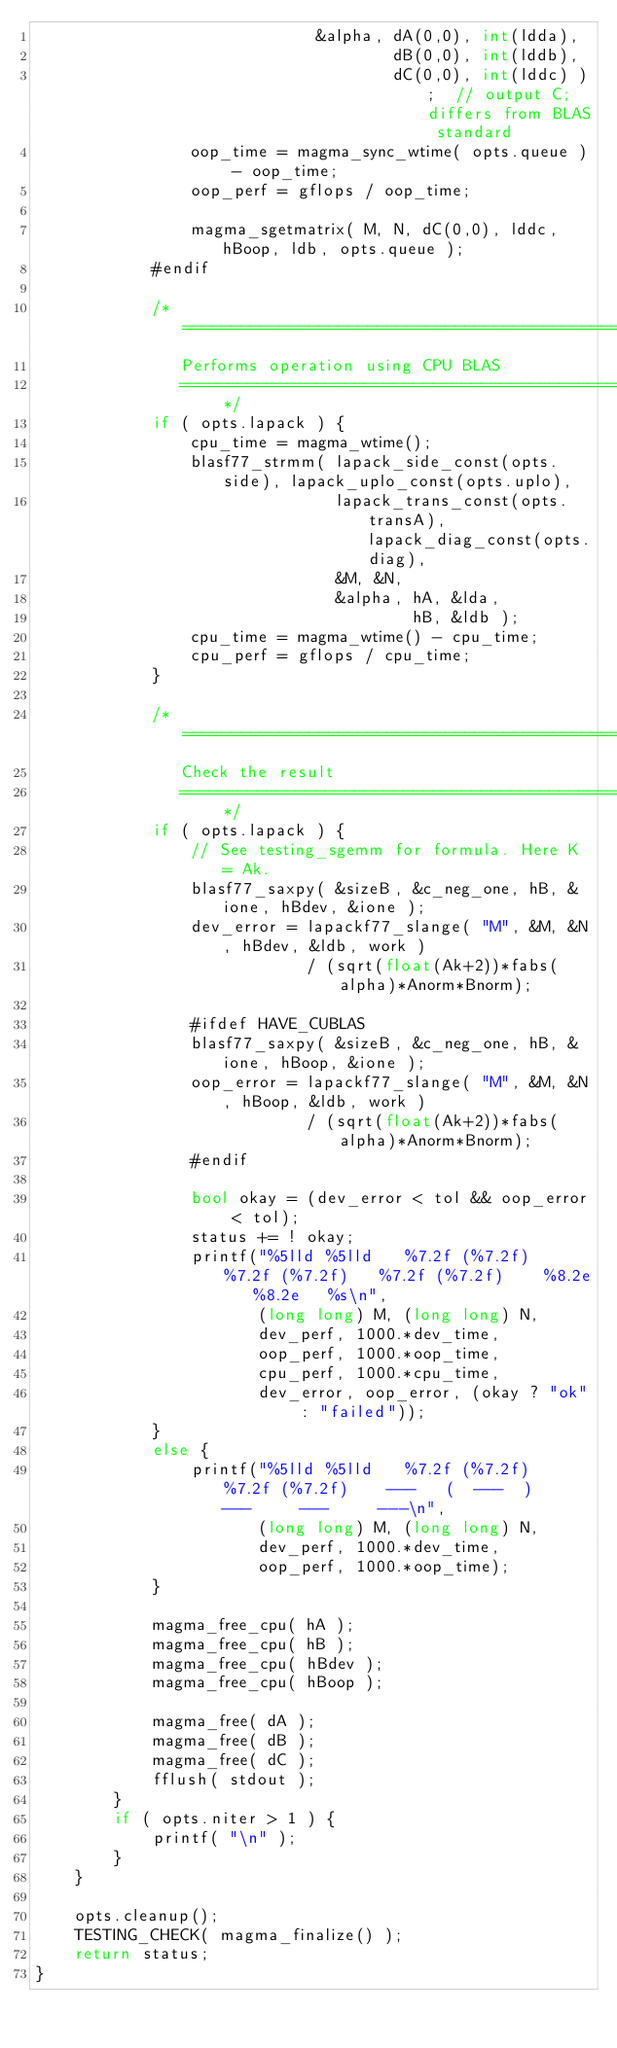<code> <loc_0><loc_0><loc_500><loc_500><_C++_>                             &alpha, dA(0,0), int(ldda),
                                     dB(0,0), int(lddb),
                                     dC(0,0), int(lddc) );  // output C; differs from BLAS standard
                oop_time = magma_sync_wtime( opts.queue ) - oop_time;
                oop_perf = gflops / oop_time;
                
                magma_sgetmatrix( M, N, dC(0,0), lddc, hBoop, ldb, opts.queue );
            #endif
            
            /* =====================================================================
               Performs operation using CPU BLAS
               =================================================================== */
            if ( opts.lapack ) {
                cpu_time = magma_wtime();
                blasf77_strmm( lapack_side_const(opts.side), lapack_uplo_const(opts.uplo),
                               lapack_trans_const(opts.transA), lapack_diag_const(opts.diag),
                               &M, &N,
                               &alpha, hA, &lda,
                                       hB, &ldb );
                cpu_time = magma_wtime() - cpu_time;
                cpu_perf = gflops / cpu_time;
            }
            
            /* =====================================================================
               Check the result
               =================================================================== */
            if ( opts.lapack ) {
                // See testing_sgemm for formula. Here K = Ak.
                blasf77_saxpy( &sizeB, &c_neg_one, hB, &ione, hBdev, &ione );
                dev_error = lapackf77_slange( "M", &M, &N, hBdev, &ldb, work )
                            / (sqrt(float(Ak+2))*fabs(alpha)*Anorm*Bnorm);
                
                #ifdef HAVE_CUBLAS
                blasf77_saxpy( &sizeB, &c_neg_one, hB, &ione, hBoop, &ione );
                oop_error = lapackf77_slange( "M", &M, &N, hBoop, &ldb, work )
                            / (sqrt(float(Ak+2))*fabs(alpha)*Anorm*Bnorm);
                #endif
                
                bool okay = (dev_error < tol && oop_error < tol);
                status += ! okay;
                printf("%5lld %5lld   %7.2f (%7.2f)   %7.2f (%7.2f)   %7.2f (%7.2f)    %8.2e   %8.2e   %s\n",
                       (long long) M, (long long) N,
                       dev_perf, 1000.*dev_time,
                       oop_perf, 1000.*oop_time,
                       cpu_perf, 1000.*cpu_time,
                       dev_error, oop_error, (okay ? "ok" : "failed"));
            }
            else {
                printf("%5lld %5lld   %7.2f (%7.2f)   %7.2f (%7.2f)    ---   (  ---  )    ---     ---     ---\n",
                       (long long) M, (long long) N,
                       dev_perf, 1000.*dev_time,
                       oop_perf, 1000.*oop_time);
            }
            
            magma_free_cpu( hA );
            magma_free_cpu( hB );
            magma_free_cpu( hBdev );
            magma_free_cpu( hBoop );
            
            magma_free( dA );
            magma_free( dB );
            magma_free( dC );
            fflush( stdout );
        }
        if ( opts.niter > 1 ) {
            printf( "\n" );
        }
    }

    opts.cleanup();
    TESTING_CHECK( magma_finalize() );
    return status;
}
</code> 